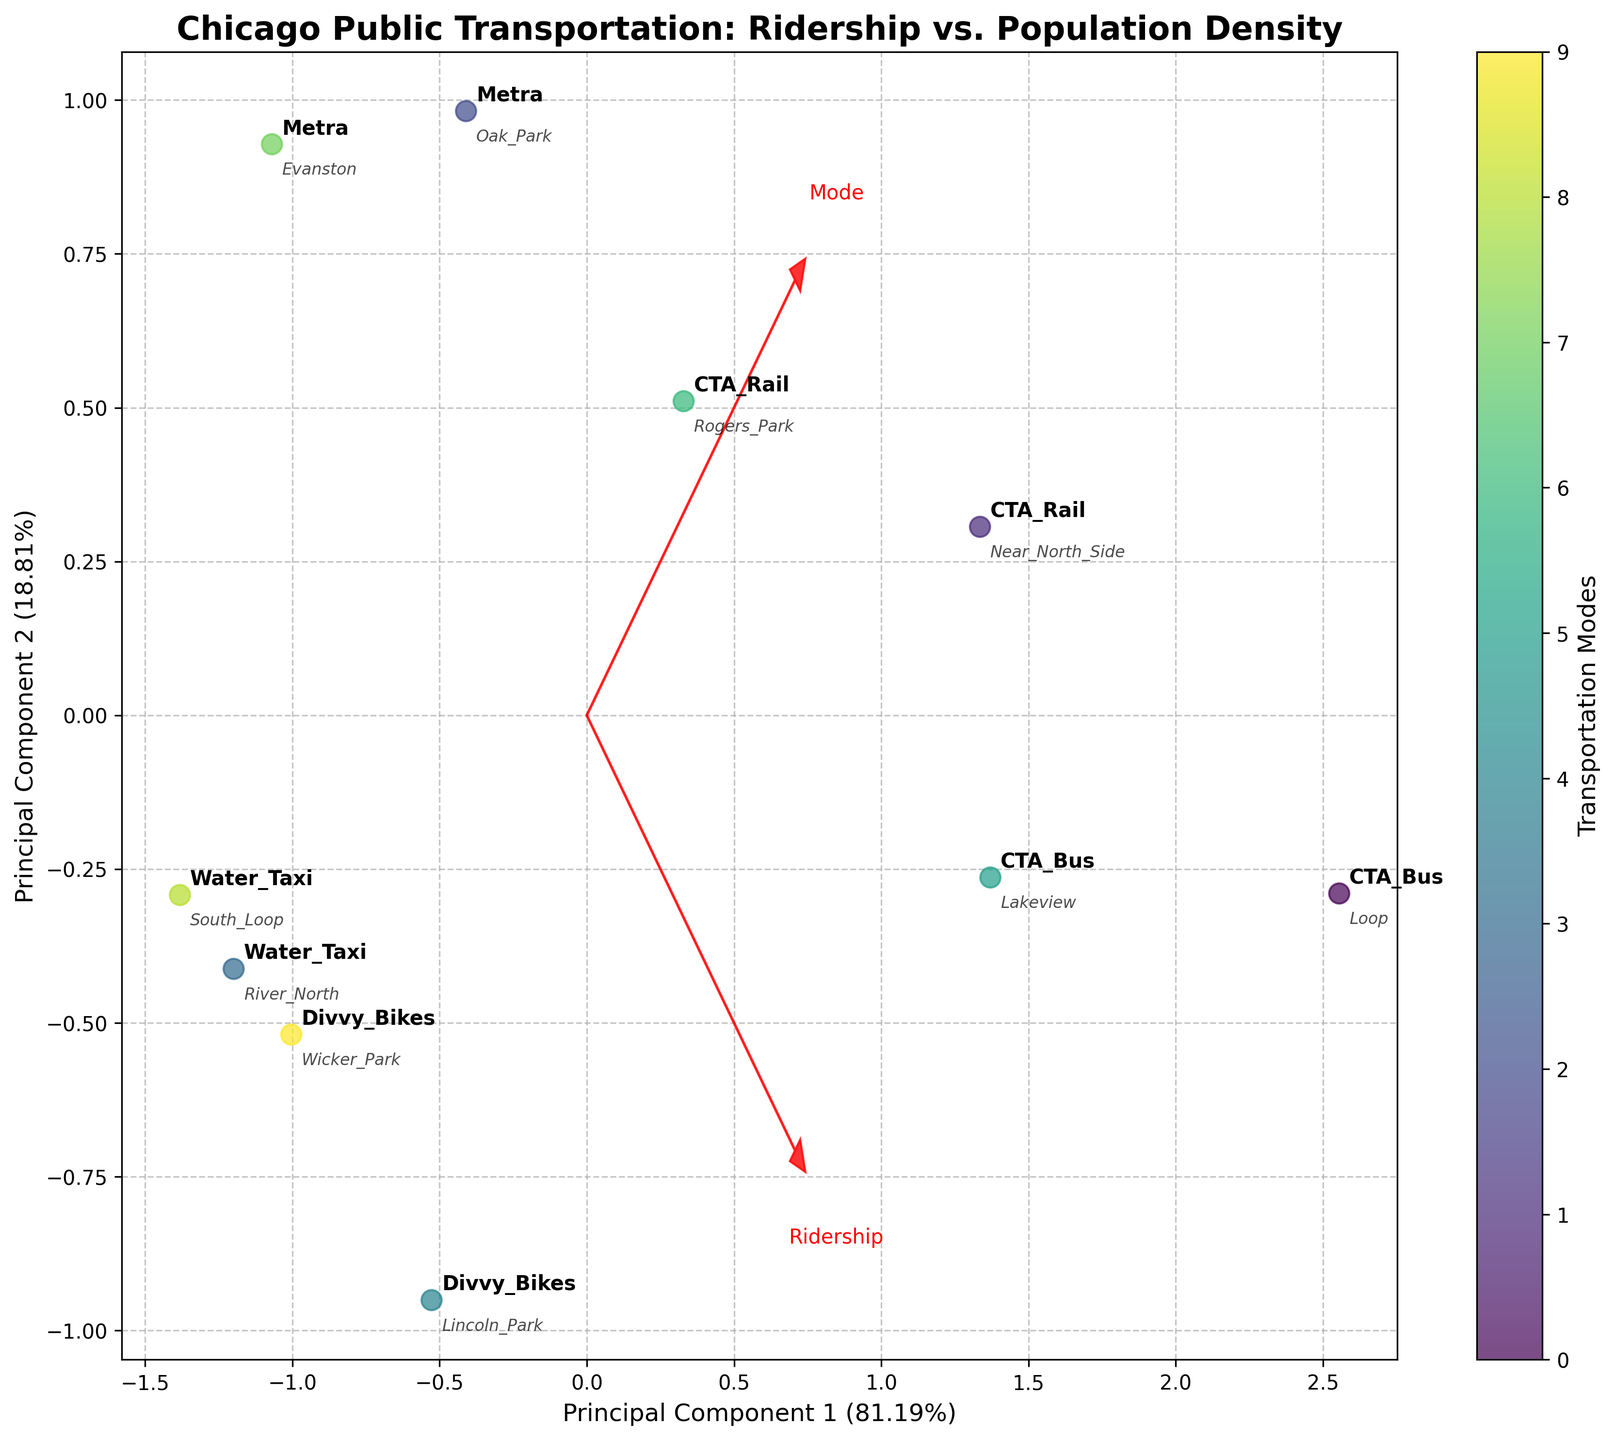Which transportation mode has the highest ridership? According to the figure, CTA Bus has the highest position in the plot, indicating that it has the highest ridership.
Answer: CTA Bus Which transportation modes appear closest to each other in terms of ridership and population density? Looking at the plot, CTA Rail and Divvy Bikes appear closest to each other, indicating they have similar ridership numbers and are in neighborhoods with comparable population densities.
Answer: CTA Rail and Divvy Bikes What does the x-axis represent in the figure? The x-axis in the PCA biplot represents the first principal component, accounting for a certain percentage of the variance in ridership and population density data.
Answer: Principal Component 1 Which neighborhood corresponding point has the lowest population density? The Metra point corresponding to Evanston in the biplot appears to be at the lower end of the population density, as it is closer to the origin compared to others.
Answer: Evanston How do the ridership patterns for Metra compare to those for CTA Bus? Compared to CTA Bus, Metra points on the plot are lower along the first principal component, indicating less ridership and appearing in neighborhoods with lower population density.
Answer: Lower ridership and population density Which feature vectors are plotted in red, and what do they represent? The red feature vectors are arrows representing the original variables (Ridership and Population Density) projected onto the principal component space.
Answer: Ridership, Population Density What percentage of variance is explained by the first principal component? The x-axis label indicates the percentage of variance explained by Principal Component 1. Refer to the plot for this exact value, typically noted in parentheses.
Answer: Percentage evident in the plot Which modes of transportation have the smallest ridership values? The Water Taxi points are plotted at a lower point, indicating smaller ridership values compared to other modes like CTA Bus and CTA Rail.
Answer: Water Taxi How is the population density related to the ridership patterns in Chicago's neighborhoods presented in the biplot? The biplot illustrates that neighborhoods with higher population density, such as the Loop and Near North Side, tend to have higher ridership values, shown by their points being further along the first principal component axis.
Answer: Higher density, Higher ridership Comparing Lakeview and South Loop, which neighborhood has higher ridership for CTA Bus? Lakeview's CTA Bus point is placed higher up in the plot compared to South Loop, indicating that Lakeview has higher ridership for CTA Bus.
Answer: Lakeview 